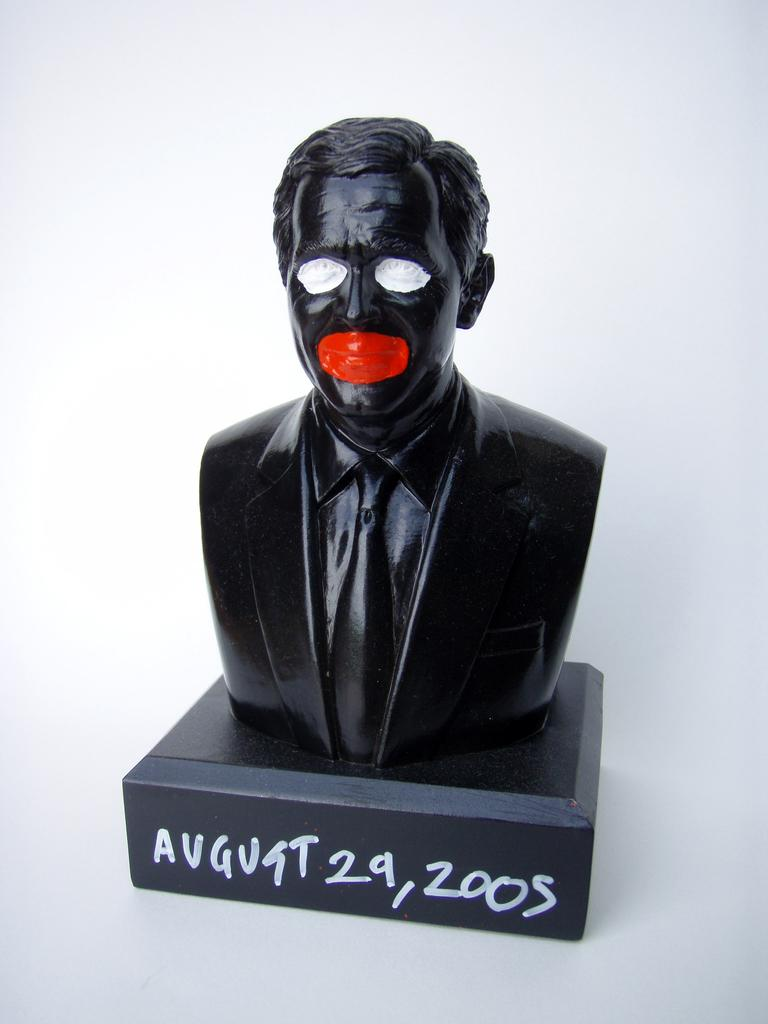What is the main subject of the image? There is a sculpture of a person in the image. What else can be seen in the image besides the sculpture? There is text on a black surface in the image. What color is the background of the image? The background of the image is white. Can you tell me how many giraffes are visible in the image? There are no giraffes present in the image. What caption is written on the black surface in the image? The provided facts do not mention any text or caption on the black surface, so we cannot determine its content. 